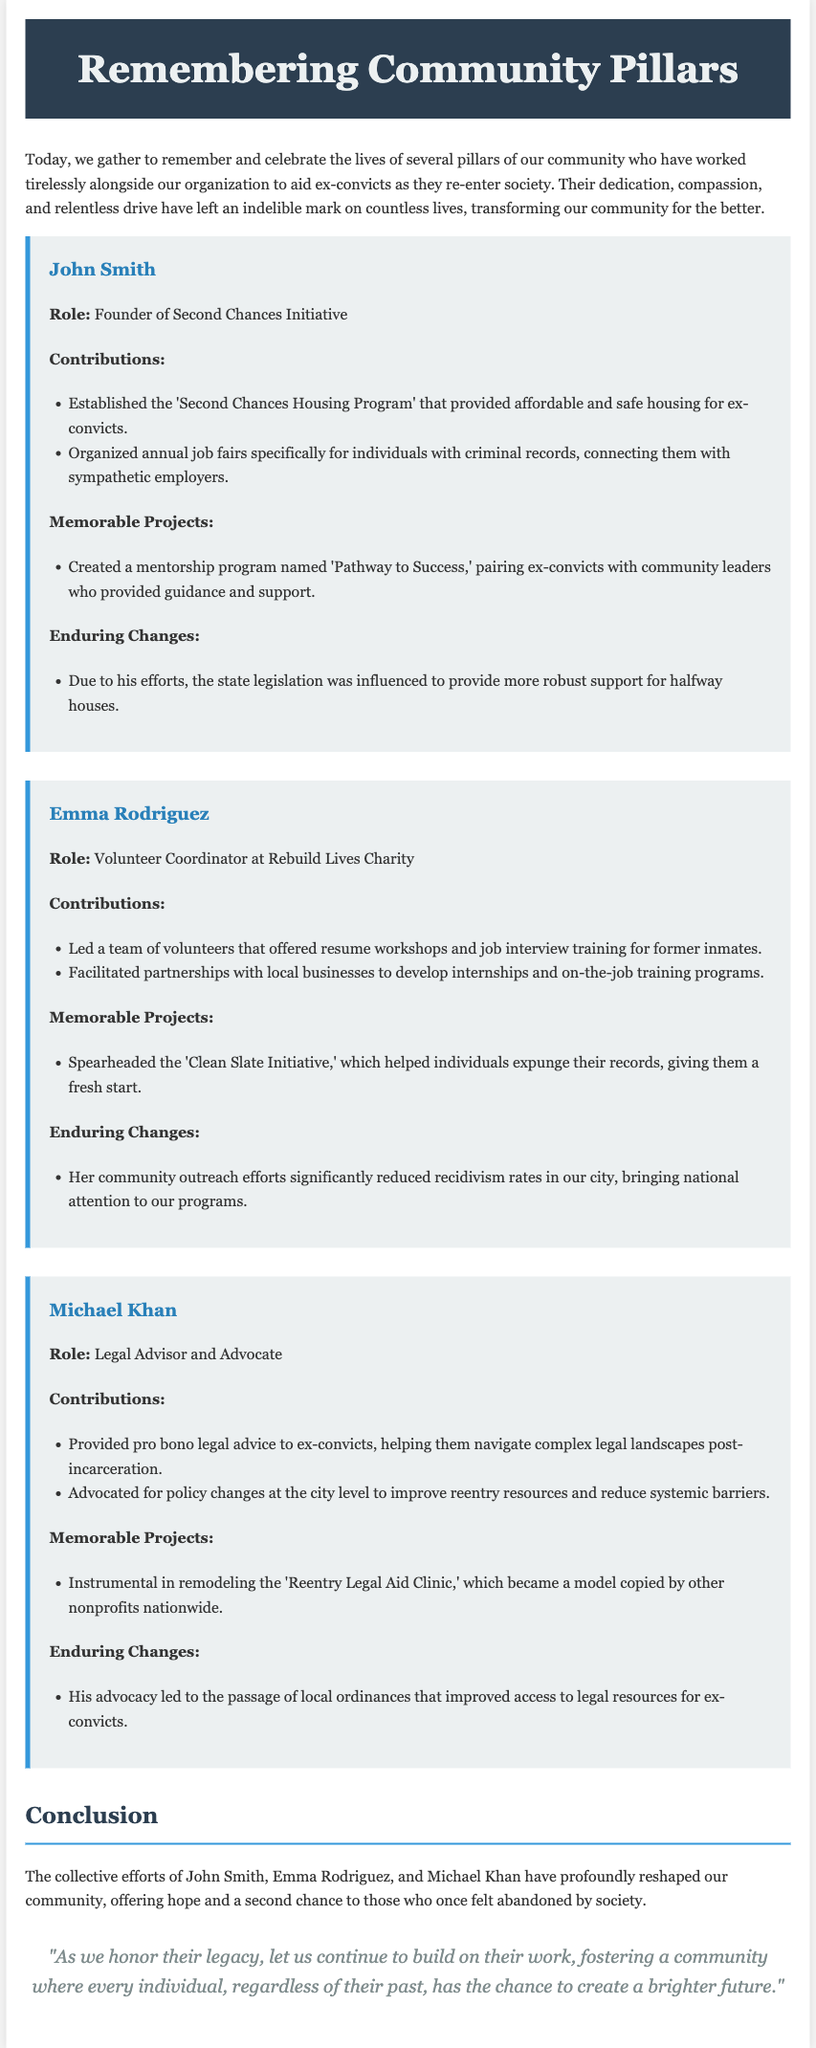What is the title of the eulogy? The title appears in the header section of the document.
Answer: Remembering Community Pillars Who is the founder of the Second Chances Initiative? The founder is mentioned in the section dedicated to individual contributions.
Answer: John Smith What notable program did Emma Rodriguez lead? This program is highlighted in the contributions section about Emma Rodriguez.
Answer: Clean Slate Initiative What is one of Michael Khan's contributions? This is specified in his contributions section detailing his role.
Answer: Provided pro bono legal advice Which community member organized annual job fairs? This is specified in the contributions of a specific individual.
Answer: John Smith What is one key effect of Emma Rodriguez’s outreach efforts? The end result of her initiatives is summarized in her enduring changes.
Answer: Reduced recidivism rates How did John Smith influence state legislation? The specific event or change is noted in John Smith's enduring changes.
Answer: More robust support for halfway houses What profession is associated with Michael Khan? This detail is included in his introductory description within the document.
Answer: Legal Advisor and Advocate What is the primary theme of the eulogy? The theme is presented in the introduction and the conclusion sections of the document.
Answer: Celebration of community leaders 